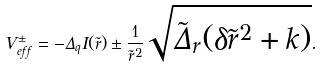<formula> <loc_0><loc_0><loc_500><loc_500>V _ { e f f } ^ { \pm } = - \Delta _ { q } I ( \tilde { r } ) \pm \frac { 1 } { \tilde { r } ^ { 2 } } \sqrt { \tilde { \Delta } _ { r } ( \delta \tilde { r } ^ { 2 } + k ) } .</formula> 